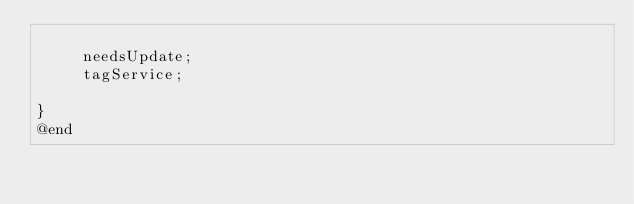Convert code to text. <code><loc_0><loc_0><loc_500><loc_500><_C_>
	 needsUpdate;
	 tagService;

}
@end

</code> 